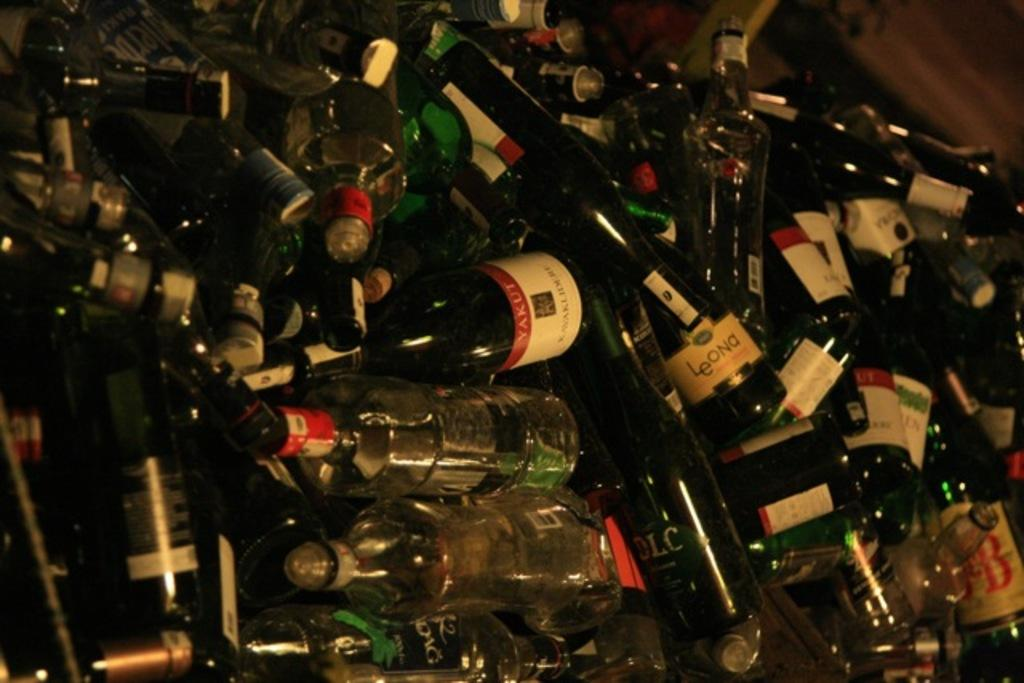<image>
Create a compact narrative representing the image presented. Many alcohol bottles, one which barely shows J and B on the label. 